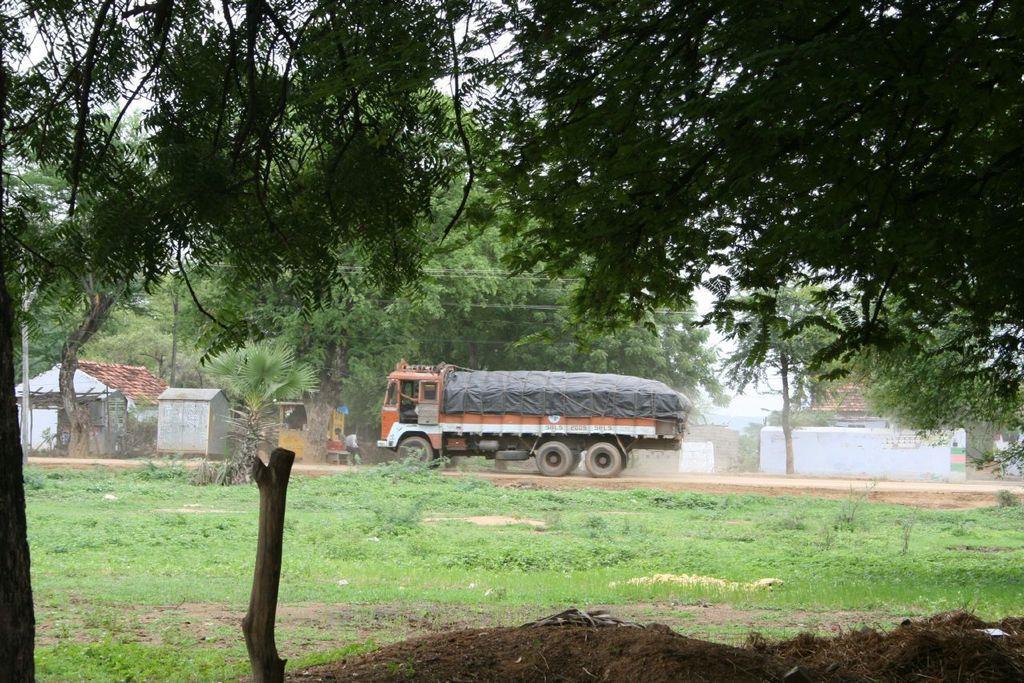Describe this image in one or two sentences. In this image I see the grass, small plants and I see the soil over here and I see the trees. In the background I see the truck on which there is a black cloth on it and I see 3 persons and I see few houses and I can also see the trees over here and I see the sky and I see the wall over here. 